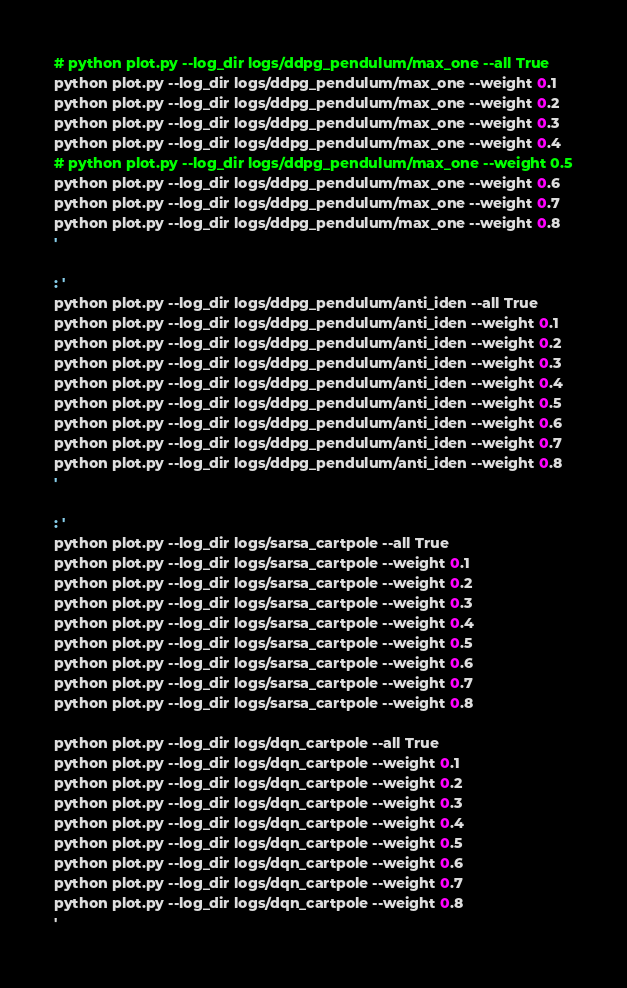Convert code to text. <code><loc_0><loc_0><loc_500><loc_500><_Bash_>
# python plot.py --log_dir logs/ddpg_pendulum/max_one --all True
python plot.py --log_dir logs/ddpg_pendulum/max_one --weight 0.1
python plot.py --log_dir logs/ddpg_pendulum/max_one --weight 0.2
python plot.py --log_dir logs/ddpg_pendulum/max_one --weight 0.3
python plot.py --log_dir logs/ddpg_pendulum/max_one --weight 0.4
# python plot.py --log_dir logs/ddpg_pendulum/max_one --weight 0.5
python plot.py --log_dir logs/ddpg_pendulum/max_one --weight 0.6
python plot.py --log_dir logs/ddpg_pendulum/max_one --weight 0.7
python plot.py --log_dir logs/ddpg_pendulum/max_one --weight 0.8
'

: '
python plot.py --log_dir logs/ddpg_pendulum/anti_iden --all True
python plot.py --log_dir logs/ddpg_pendulum/anti_iden --weight 0.1
python plot.py --log_dir logs/ddpg_pendulum/anti_iden --weight 0.2
python plot.py --log_dir logs/ddpg_pendulum/anti_iden --weight 0.3
python plot.py --log_dir logs/ddpg_pendulum/anti_iden --weight 0.4
python plot.py --log_dir logs/ddpg_pendulum/anti_iden --weight 0.5
python plot.py --log_dir logs/ddpg_pendulum/anti_iden --weight 0.6
python plot.py --log_dir logs/ddpg_pendulum/anti_iden --weight 0.7
python plot.py --log_dir logs/ddpg_pendulum/anti_iden --weight 0.8
'

: '
python plot.py --log_dir logs/sarsa_cartpole --all True
python plot.py --log_dir logs/sarsa_cartpole --weight 0.1
python plot.py --log_dir logs/sarsa_cartpole --weight 0.2
python plot.py --log_dir logs/sarsa_cartpole --weight 0.3
python plot.py --log_dir logs/sarsa_cartpole --weight 0.4
python plot.py --log_dir logs/sarsa_cartpole --weight 0.5
python plot.py --log_dir logs/sarsa_cartpole --weight 0.6
python plot.py --log_dir logs/sarsa_cartpole --weight 0.7
python plot.py --log_dir logs/sarsa_cartpole --weight 0.8

python plot.py --log_dir logs/dqn_cartpole --all True
python plot.py --log_dir logs/dqn_cartpole --weight 0.1
python plot.py --log_dir logs/dqn_cartpole --weight 0.2
python plot.py --log_dir logs/dqn_cartpole --weight 0.3
python plot.py --log_dir logs/dqn_cartpole --weight 0.4
python plot.py --log_dir logs/dqn_cartpole --weight 0.5
python plot.py --log_dir logs/dqn_cartpole --weight 0.6
python plot.py --log_dir logs/dqn_cartpole --weight 0.7
python plot.py --log_dir logs/dqn_cartpole --weight 0.8
'
</code> 